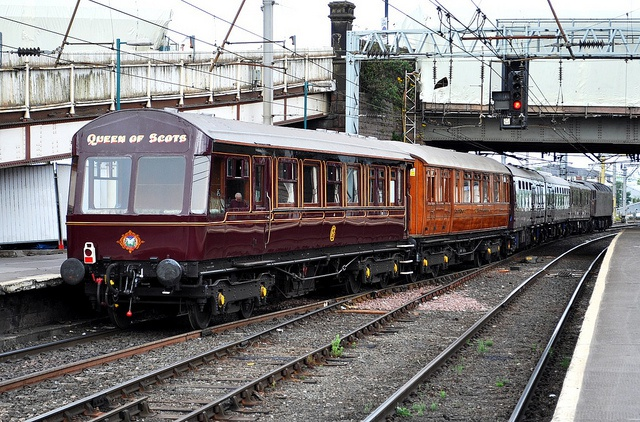Describe the objects in this image and their specific colors. I can see train in white, black, gray, lightgray, and darkgray tones and traffic light in white, black, gray, and lightgray tones in this image. 